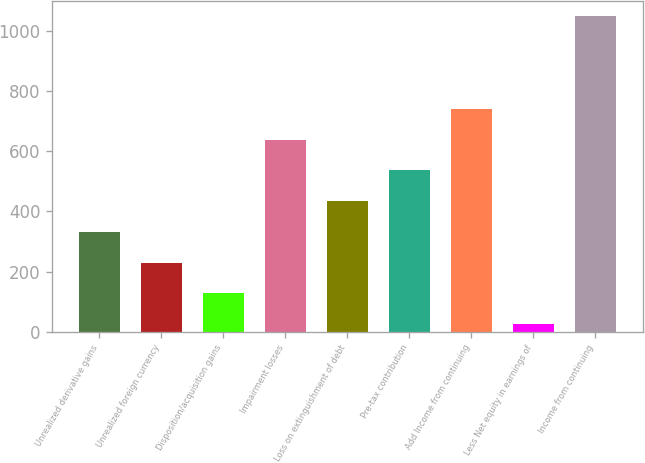<chart> <loc_0><loc_0><loc_500><loc_500><bar_chart><fcel>Unrealized derivative gains<fcel>Unrealized foreign currency<fcel>Disposition/acquisition gains<fcel>Impairment losses<fcel>Loss on extinguishment of debt<fcel>Pre-tax contribution<fcel>Add Income from continuing<fcel>Less Net equity in earnings of<fcel>Income from continuing<nl><fcel>331.9<fcel>229.6<fcel>127.3<fcel>638.8<fcel>434.2<fcel>536.5<fcel>741.1<fcel>25<fcel>1048<nl></chart> 